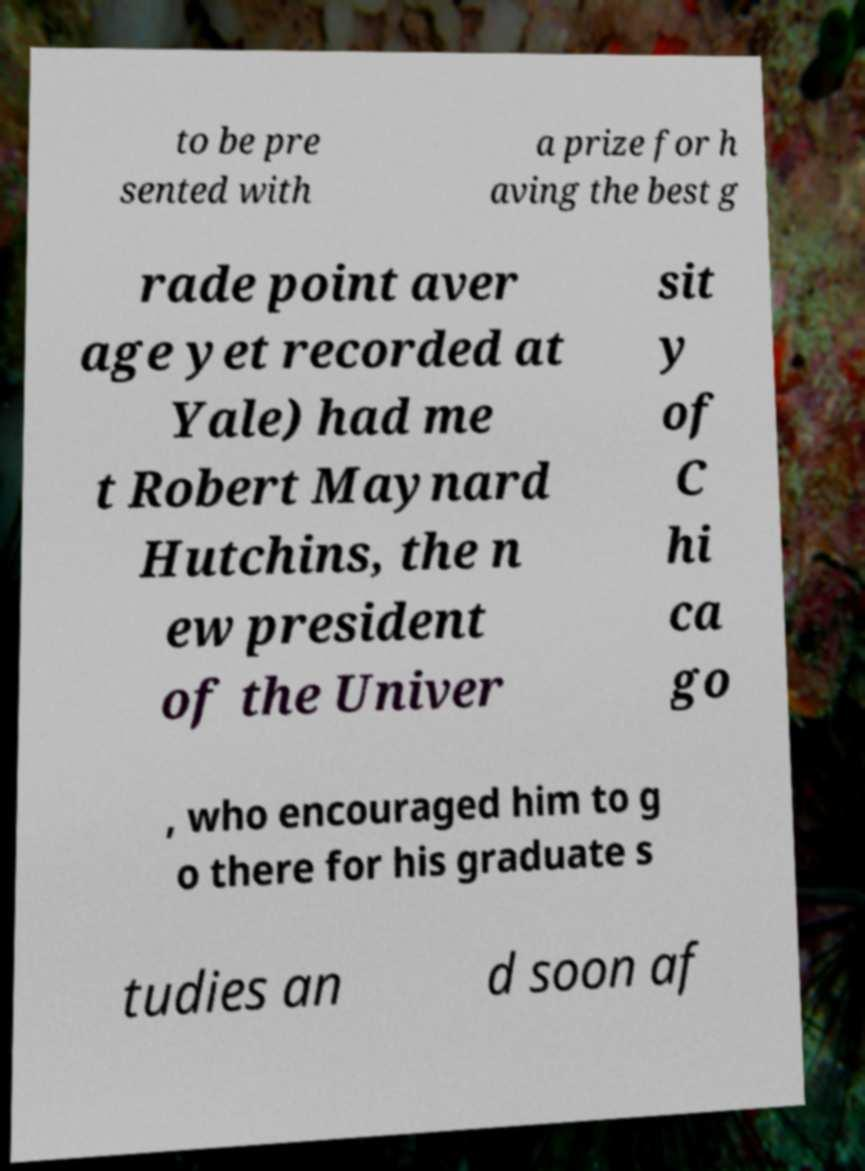Could you assist in decoding the text presented in this image and type it out clearly? to be pre sented with a prize for h aving the best g rade point aver age yet recorded at Yale) had me t Robert Maynard Hutchins, the n ew president of the Univer sit y of C hi ca go , who encouraged him to g o there for his graduate s tudies an d soon af 